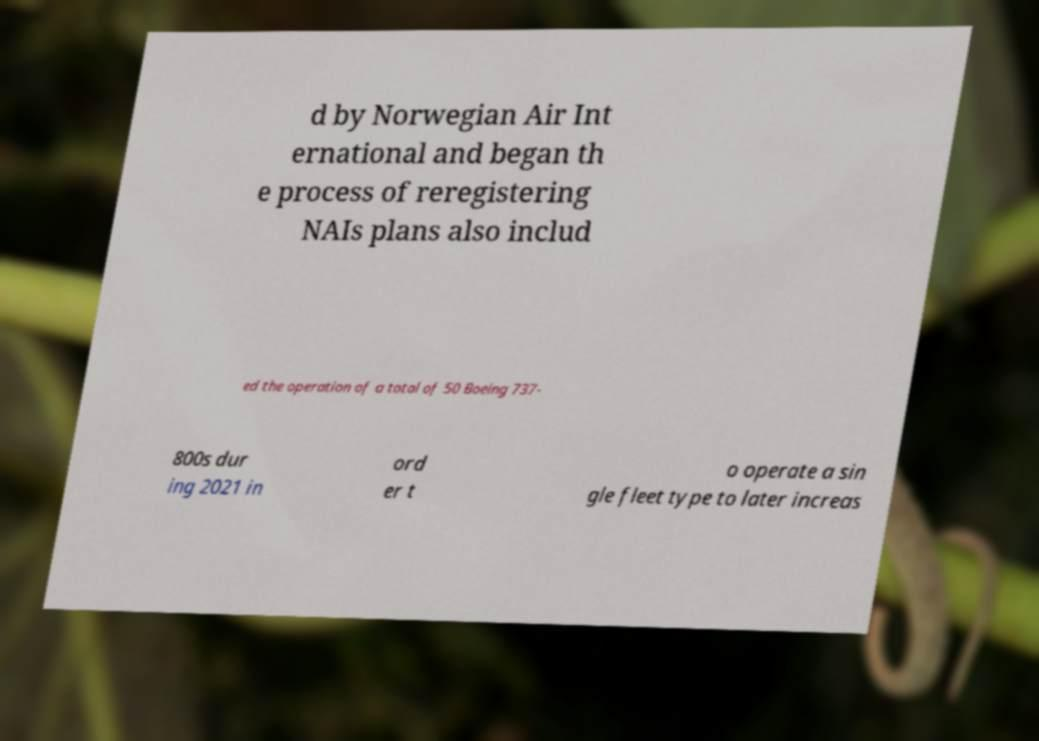I need the written content from this picture converted into text. Can you do that? d by Norwegian Air Int ernational and began th e process of reregistering NAIs plans also includ ed the operation of a total of 50 Boeing 737- 800s dur ing 2021 in ord er t o operate a sin gle fleet type to later increas 